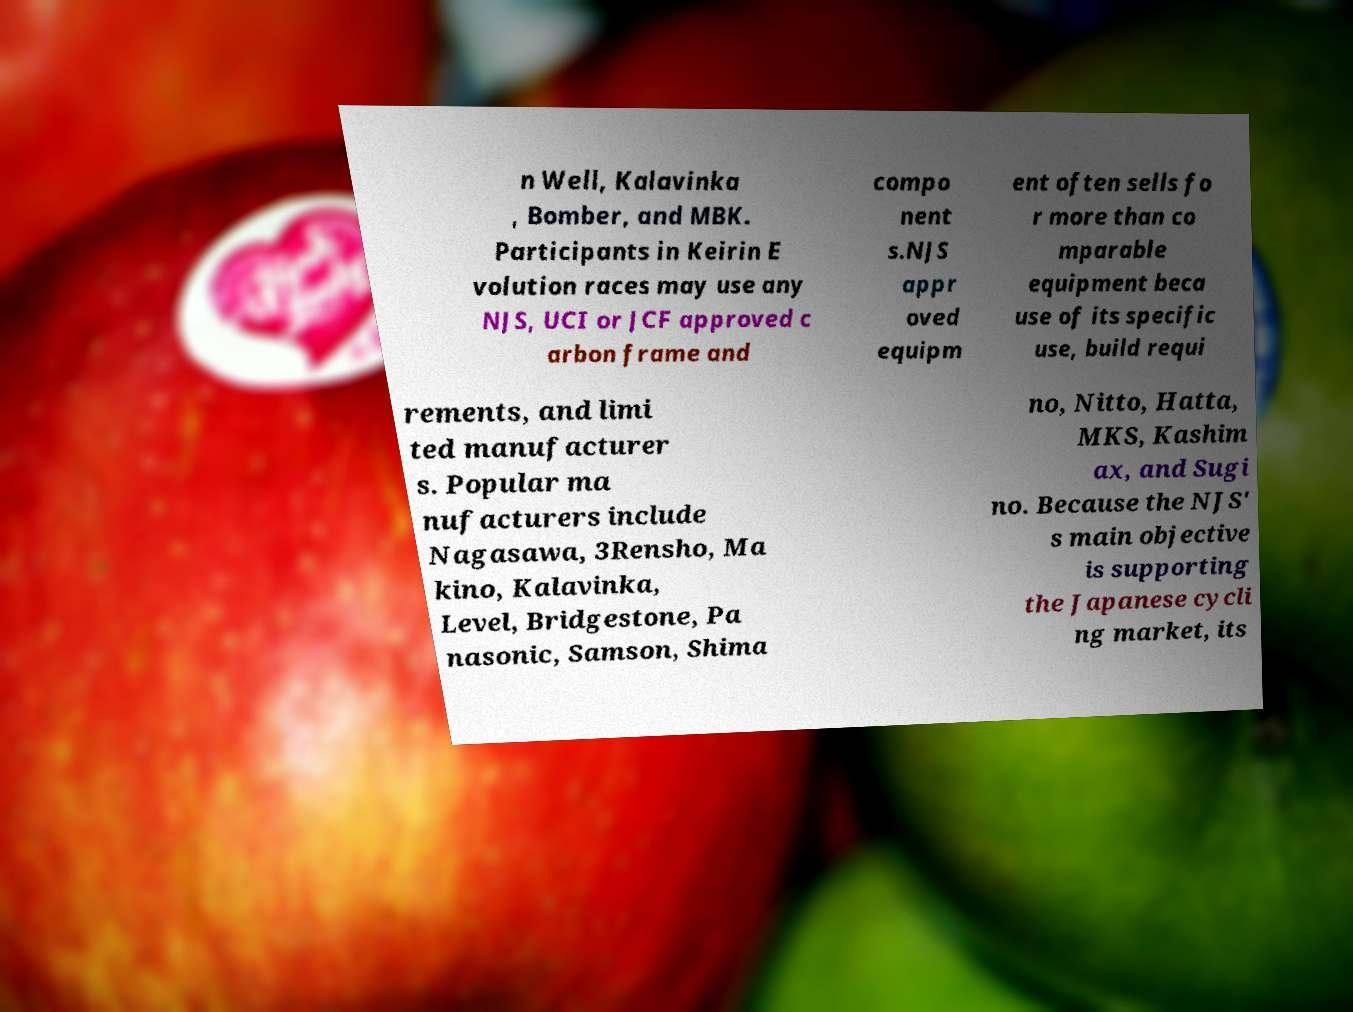Can you accurately transcribe the text from the provided image for me? n Well, Kalavinka , Bomber, and MBK. Participants in Keirin E volution races may use any NJS, UCI or JCF approved c arbon frame and compo nent s.NJS appr oved equipm ent often sells fo r more than co mparable equipment beca use of its specific use, build requi rements, and limi ted manufacturer s. Popular ma nufacturers include Nagasawa, 3Rensho, Ma kino, Kalavinka, Level, Bridgestone, Pa nasonic, Samson, Shima no, Nitto, Hatta, MKS, Kashim ax, and Sugi no. Because the NJS' s main objective is supporting the Japanese cycli ng market, its 